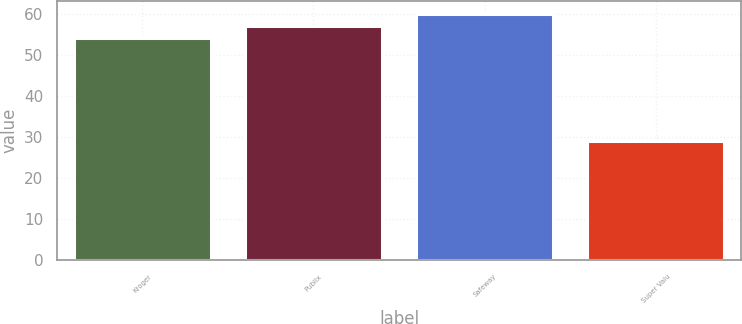Convert chart to OTSL. <chart><loc_0><loc_0><loc_500><loc_500><bar_chart><fcel>Kroger<fcel>Publix<fcel>Safeway<fcel>Super Valu<nl><fcel>54<fcel>57<fcel>60<fcel>29<nl></chart> 